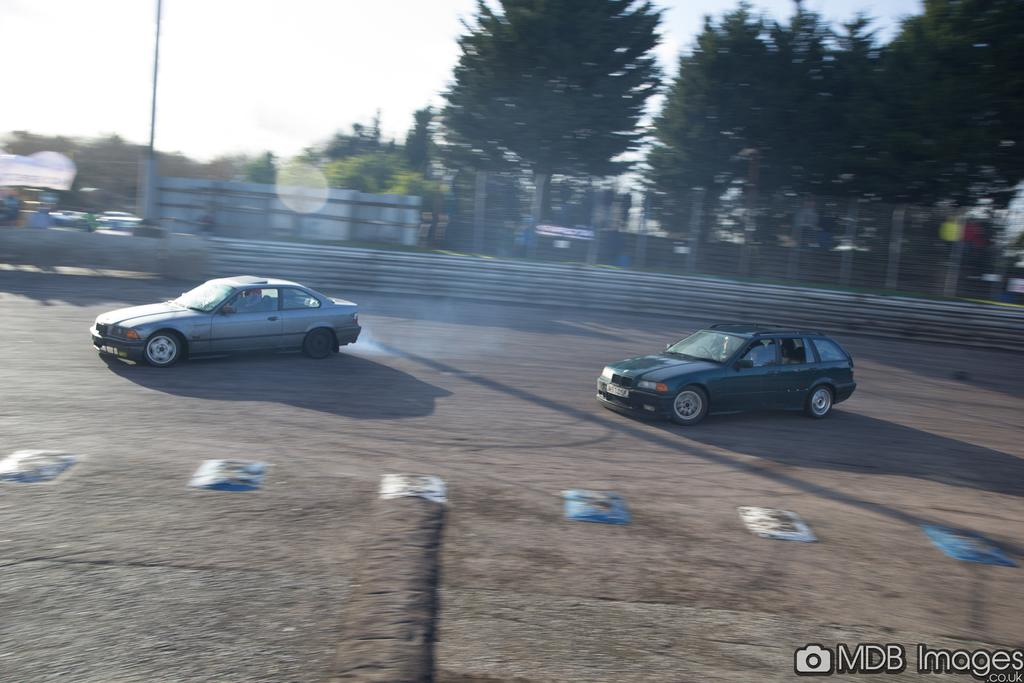What can be seen on the road in the image? There are vehicles on the road in the image. What is visible in the background of the image? There are trees, poles, a fence, and other objects in the background of the image. Can you describe the text at the bottom of the image? There is some text at the bottom of the image. What is the logo at the bottom of the image? There is a logo at the bottom of the image. How many balloons are floating in the sky in the image? There are no balloons visible in the image. What type of form is being filled out by the people in the image? There are no people or forms present in the image. 